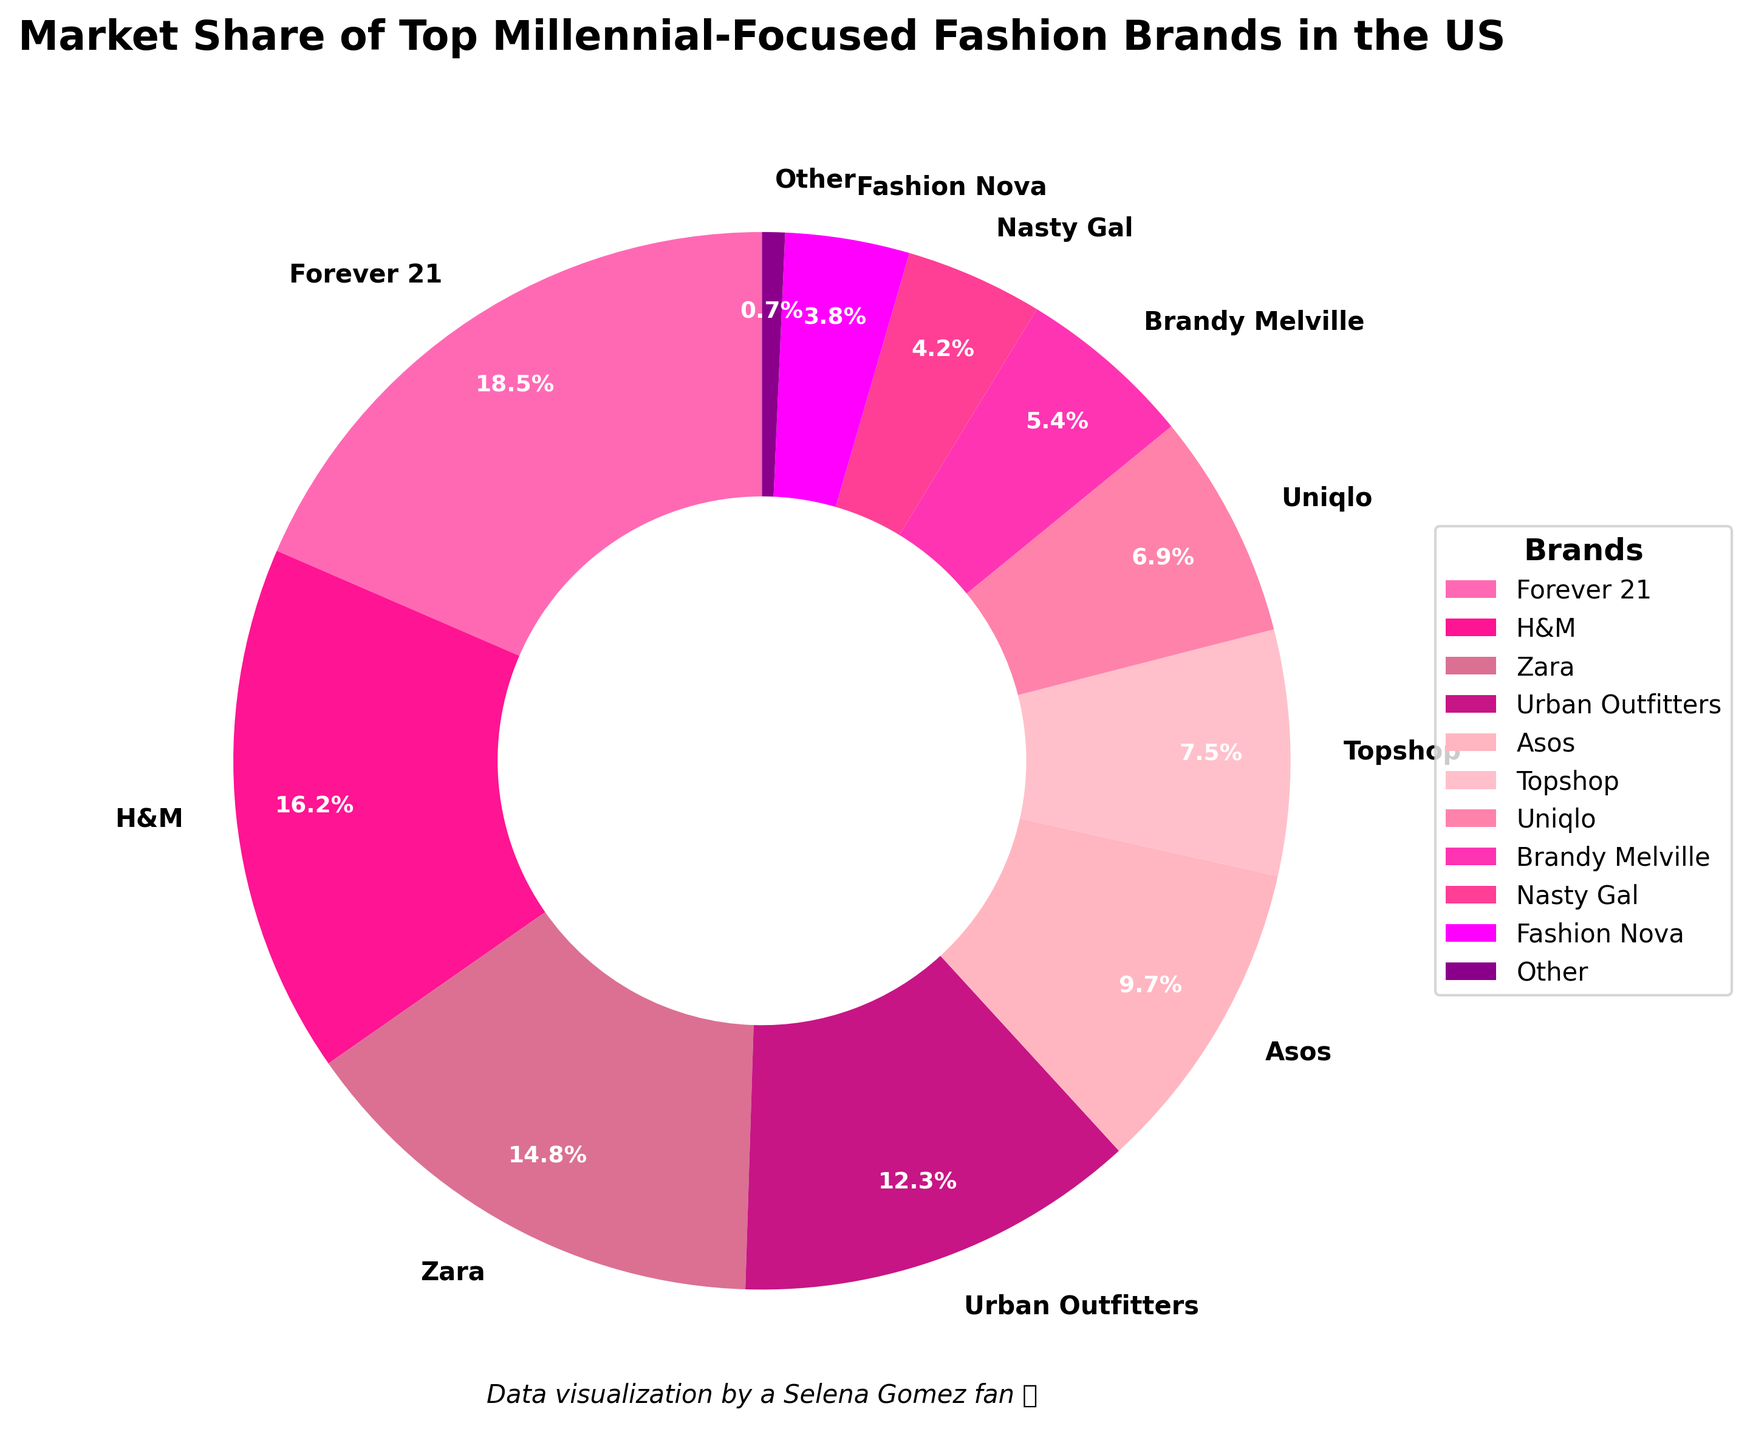What are the two brands with the highest market share? To identify the two brands with the highest market share, we look at the pie chart and see which wedges are the largest. From the labels on the chart, Forever 21 and H&M have the highest shares at 18.5% and 16.2% respectively.
Answer: Forever 21 and H&M Which brand has the lowest market share, and what is it? To find the brand with the lowest market share, we look for the smallest wedge in the pie chart. According to the labels, the 'Other' category has the smallest share at 0.7%.
Answer: Other, 0.7% How much greater is the market share of Forever 21 compared to Fashion Nova? The market share of Forever 21 is 18.5%, while Fashion Nova's is 3.8%. The difference is calculated as 18.5% - 3.8%. This gives us 14.7%.
Answer: 14.7% What's the combined market share of Urban Outfitters and Asos? To find the combined market share, we add the percentages of both brands. Urban Outfitters has 12.3% and Asos has 9.7%. Adding these together, 12.3% + 9.7% = 22.0%.
Answer: 22.0% Which color represents Topshop? We identify the wedge for Topshop in the pie chart and note the color used. The wedge for Topshop is labeled on the pie chart and its color is a light pink shade.
Answer: Light pink Is the market share of Brandy Melville higher or lower than Nasty Gal? By how much? We check the market shares of Brandy Melville, which is 5.4%, and Nasty Gal, which is 4.2%. The difference between them is 5.4% - 4.2% = 1.2%.
Answer: Higher, by 1.2% What is the total market share of brands other than the top three? First, sum the shares of the top three brands: Forever 21 (18.5%), H&M (16.2%), and Zara (14.8%) which adds up to 49.5%. Then subtract this from 100% to get the remaining market share: 100% - 49.5% = 50.5%.
Answer: 50.5% Which four brands together make up approximately half of the market share? Adding up the market shares, we aim for a sum close to 50%. H&M (16.2%), Zara (14.8%), Urban Outfitters (12.3%), and Asos (9.7%) sum to 53%.
Answer: H&M, Zara, Urban Outfitters, Asos How many brands have a market share greater than 10%? We look at the market shares for each brand and count those greater than 10%. These are Forever 21 (18.5%), H&M (16.2%), Zara (14.8%), and Urban Outfitters (12.3%)—a total of four brands.
Answer: 4 